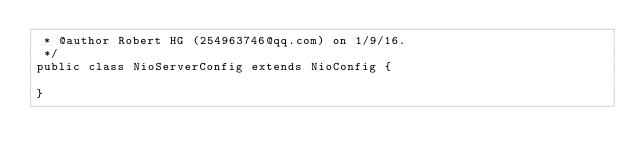Convert code to text. <code><loc_0><loc_0><loc_500><loc_500><_Java_> * @author Robert HG (254963746@qq.com) on 1/9/16.
 */
public class NioServerConfig extends NioConfig {

}
</code> 